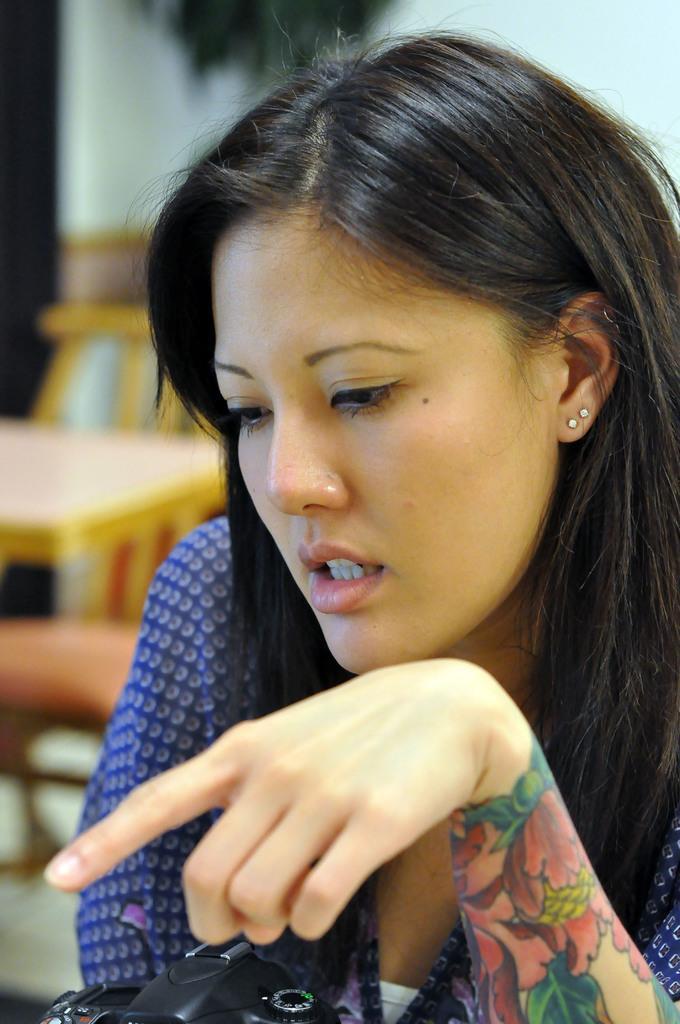Please provide a concise description of this image. In this image there is a woman with a tattoo on her hand , there is a camera , and in the background there is a table, chairs and a wall. 